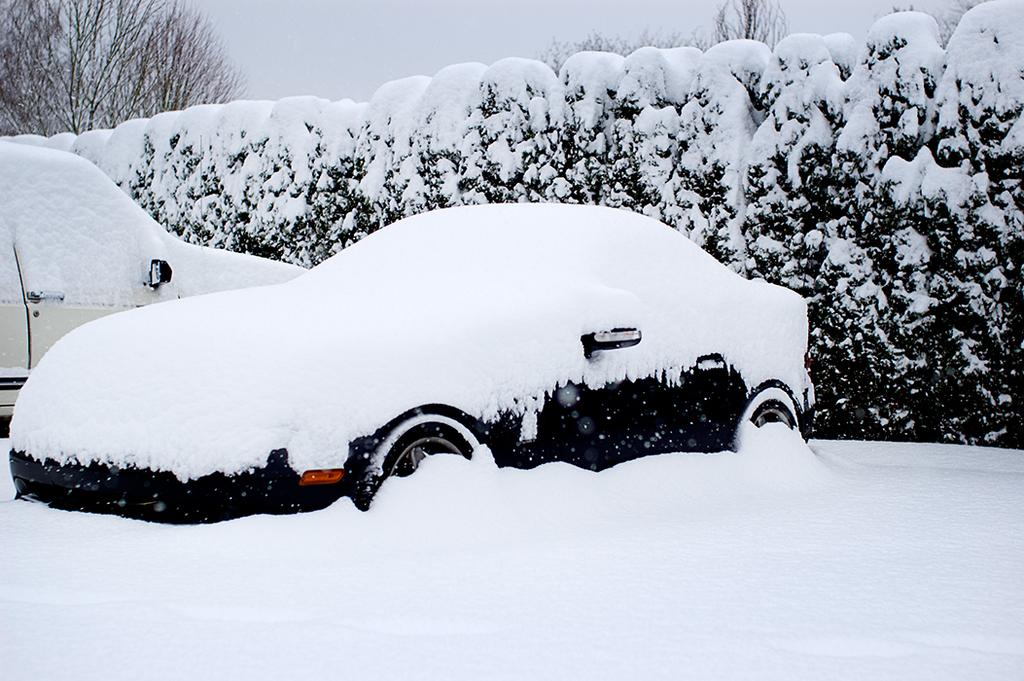How many cars are in the image? There are two cars in the image. What is the condition of the ground in the image? The cars are in the snow, and snow is covering the ground. What else is covered in snow in the image? Snow is also covering the plants and trees visible in the image. What type of apple can be seen in the image? There is no apple present in the image; it features two cars in the snow with plants and trees also covered in snow. What shape is the bath in the image? There is no bath present in the image. 